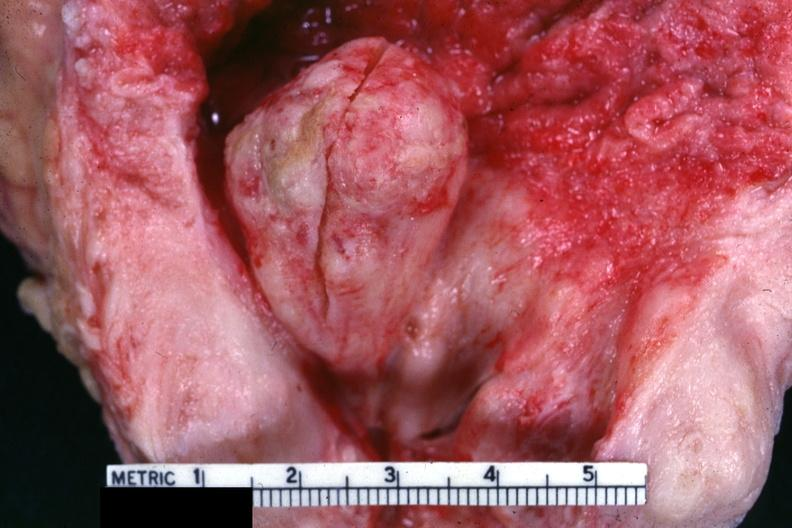s hyperplasia present?
Answer the question using a single word or phrase. Yes 